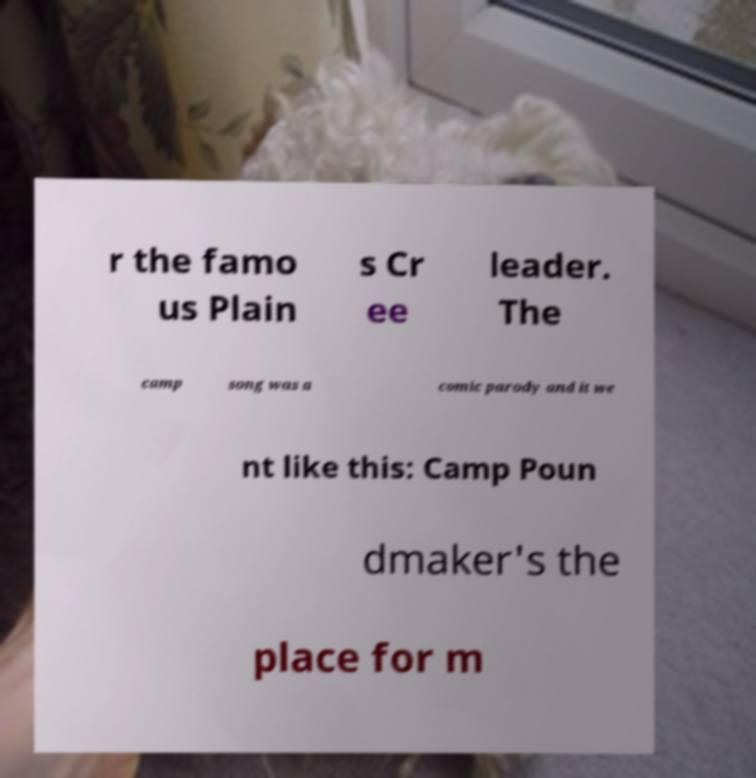Please identify and transcribe the text found in this image. r the famo us Plain s Cr ee leader. The camp song was a comic parody and it we nt like this: Camp Poun dmaker's the place for m 